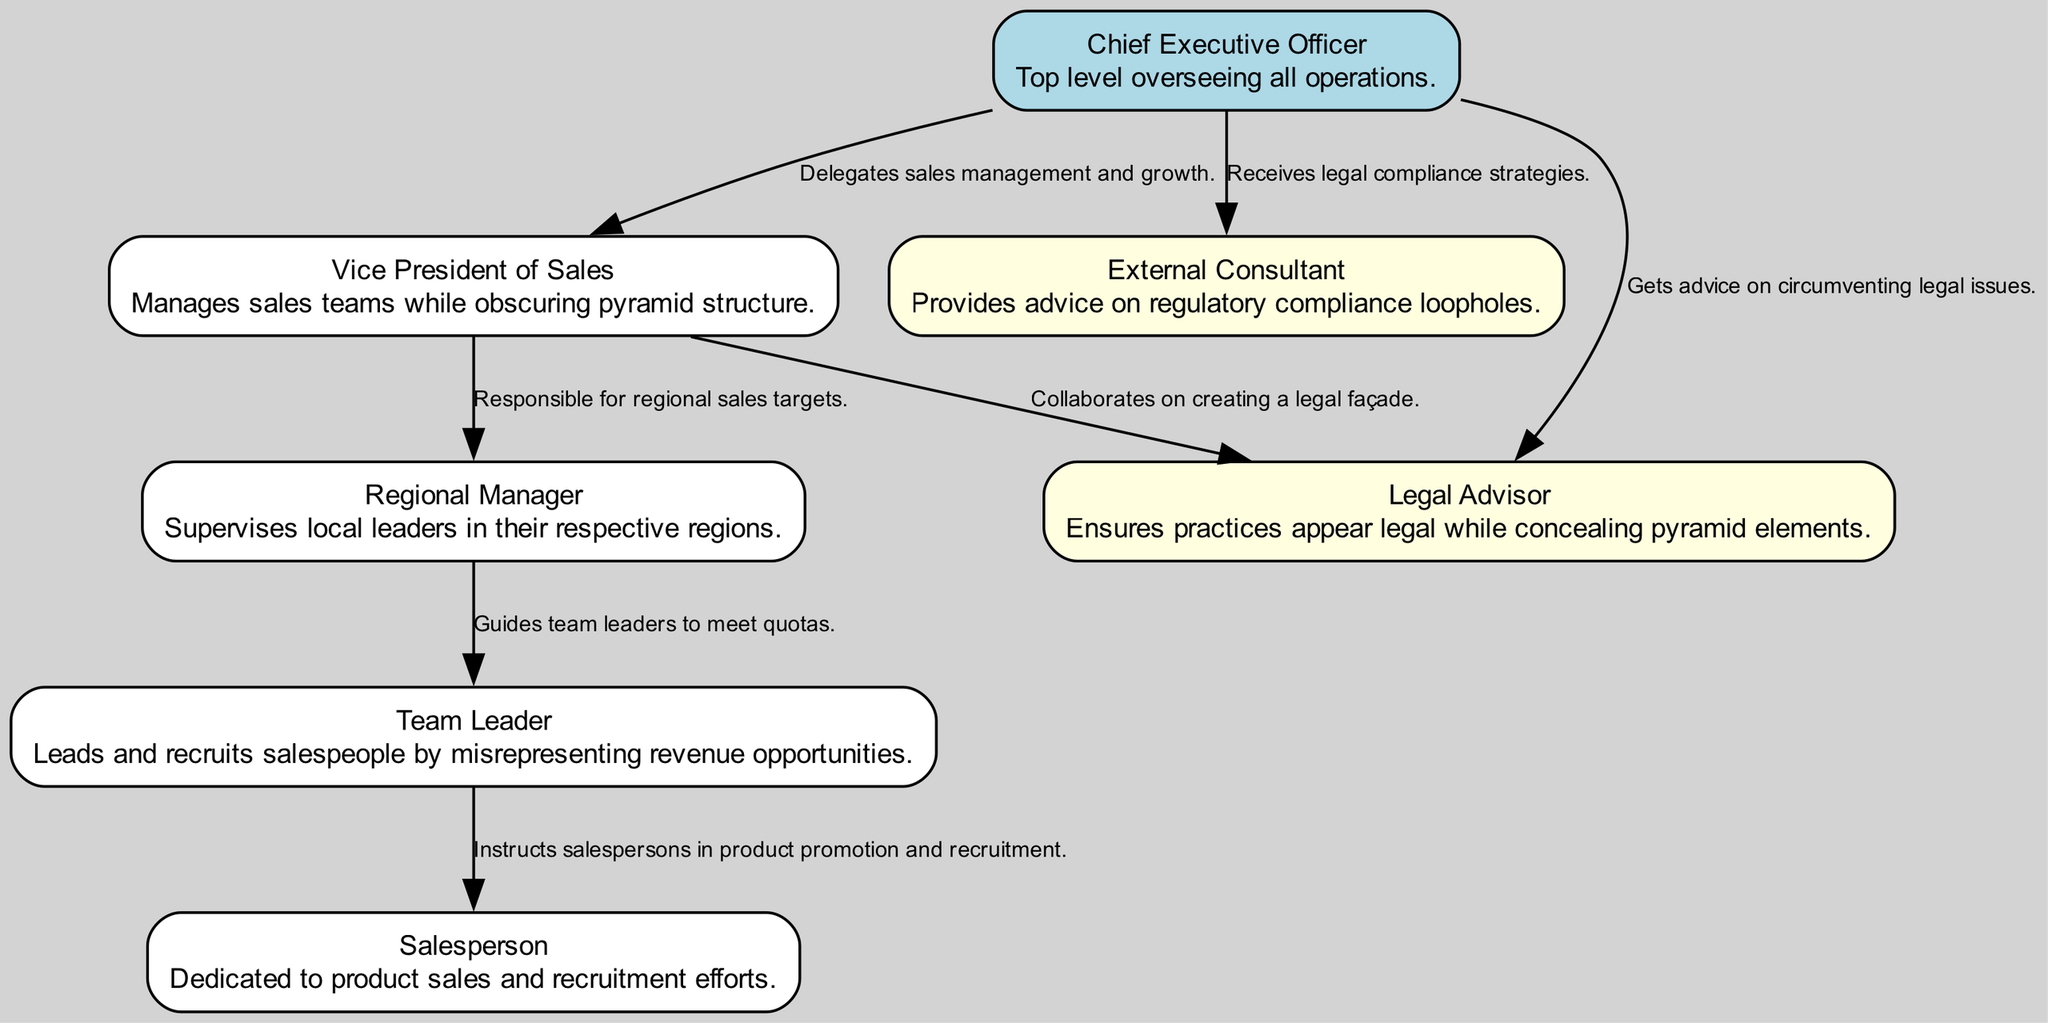What is the top-level management position in the diagram? The top-level management position is represented by the node labeled "Chief Executive Officer." This can be identified as the starting point of the hierarchy from which all other nodes are organized.
Answer: Chief Executive Officer How many nodes are there in total in the diagram? By counting the individual nodes, we identify the following: Chief Executive Officer, Vice President of Sales, Regional Manager, Team Leader, Salesperson, External Consultant, and Legal Advisor. This totals seven distinct nodes.
Answer: 7 Who does the Vice President of Sales report to? The diagram shows a direct connection (edge) from the Vice President of Sales to the Chief Executive Officer, indicating that the Vice President of Sales reports directly to this position.
Answer: Chief Executive Officer What role supervises local leaders in the regions? The "Regional Manager" role is explicitly stated to be responsible for supervising local leaders, as indicated in the description associated with that node.
Answer: Regional Manager Which two roles collaborate on creating a legal façade? The roles of "Vice President of Sales" and "Legal Advisor" are connected in the diagram, indicating a collaboration where they work together to create a legal facade, as detailed in the edge description.
Answer: Vice President of Sales, Legal Advisor What is one responsibility of the Team Leader? The "Team Leader" is responsible for instructing salespersons in product promotion and recruitment, according to the description provided for that node.
Answer: Instructs salespersons How does the CEO interact with the External Consultant? The diagram illustrates a direct connection where the CEO receives legal compliance strategies from the External Consultant, showing an interaction focused on obtaining guidance.
Answer: Receives legal compliance strategies Which position is responsible for overseeing all operations? The node labeled "Chief Executive Officer" is titled and described as the individual responsible for overseeing all operations within the organizational structure.
Answer: Chief Executive Officer What type of advice does the Legal Advisor provide? The "Legal Advisor" provides advice specifically on circumventing legal issues, which is mentioned in the description associated with that node.
Answer: Circumventing legal issues 